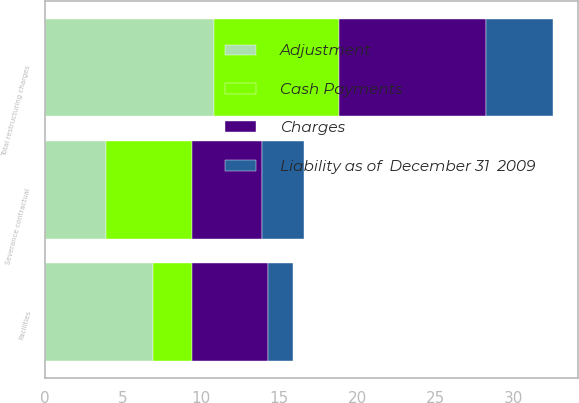Convert chart. <chart><loc_0><loc_0><loc_500><loc_500><stacked_bar_chart><ecel><fcel>Facilities<fcel>Severance contractual<fcel>Total restructuring charges<nl><fcel>Charges<fcel>4.9<fcel>4.5<fcel>9.4<nl><fcel>Adjustment<fcel>6.9<fcel>3.9<fcel>10.8<nl><fcel>Cash Payments<fcel>2.5<fcel>5.5<fcel>8<nl><fcel>Liability as of  December 31  2009<fcel>1.6<fcel>2.7<fcel>4.3<nl></chart> 